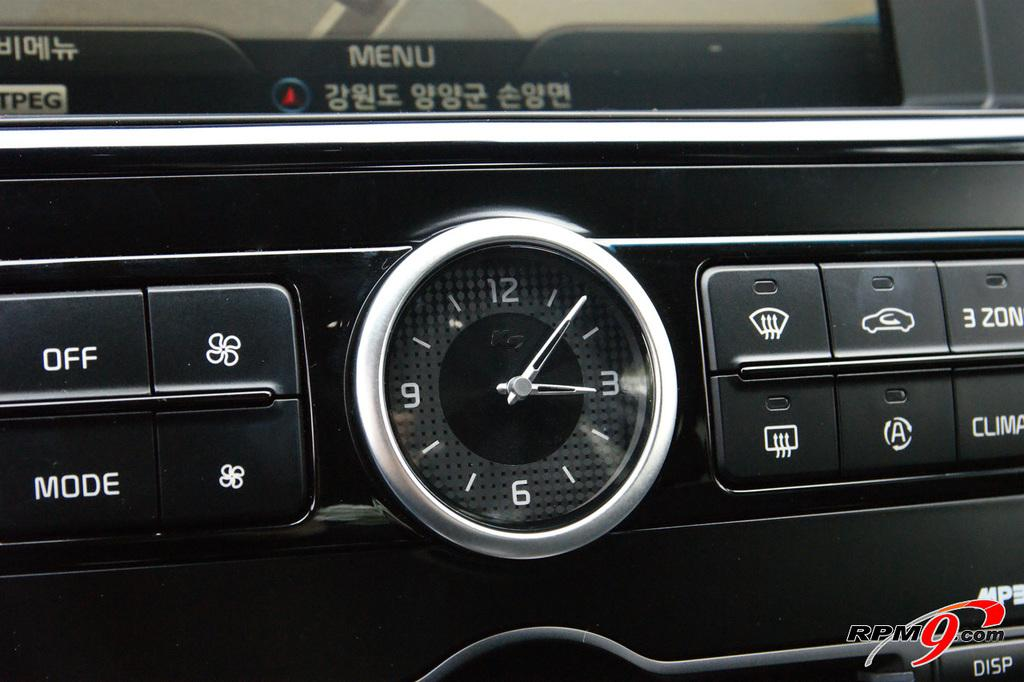What is the main object in the image? There is a device in the image. What feature does the device have? The device has a clock. What else can be found on the device? The device has switches. How many turkeys can be seen on the device in the image? There are no turkeys present on the device in the image. What level of difficulty is the squirrel playing on the device in the image? There is no squirrel or any game present on the device in the image. 